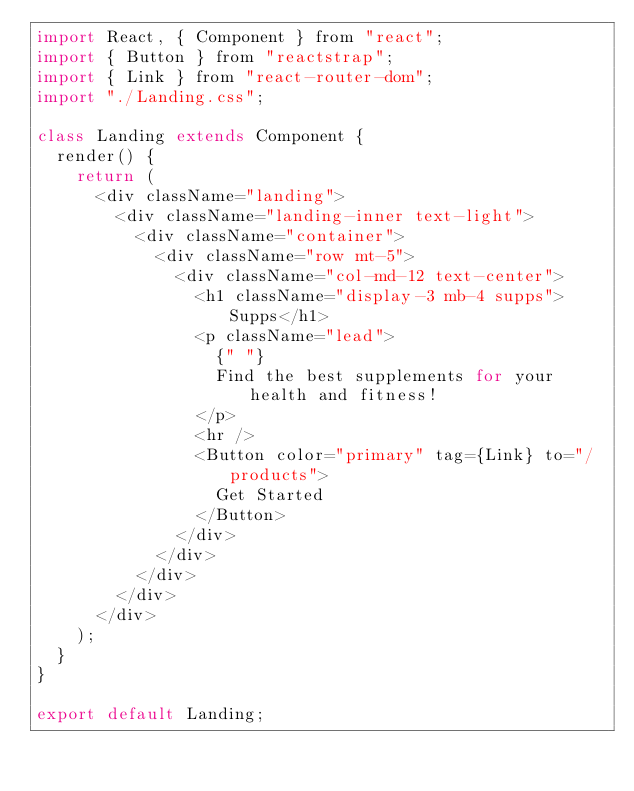<code> <loc_0><loc_0><loc_500><loc_500><_JavaScript_>import React, { Component } from "react";
import { Button } from "reactstrap";
import { Link } from "react-router-dom";
import "./Landing.css";

class Landing extends Component {
  render() {
    return (
      <div className="landing">
        <div className="landing-inner text-light">
          <div className="container">
            <div className="row mt-5">
              <div className="col-md-12 text-center">
                <h1 className="display-3 mb-4 supps">Supps</h1>
                <p className="lead">
                  {" "}
                  Find the best supplements for your health and fitness!
                </p>
                <hr />
                <Button color="primary" tag={Link} to="/products">
                  Get Started
                </Button>
              </div>
            </div>
          </div>
        </div>
      </div>
    );
  }
}

export default Landing;
</code> 